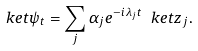Convert formula to latex. <formula><loc_0><loc_0><loc_500><loc_500>\ k e t { \psi _ { t } } = \sum _ { j } \alpha _ { j } e ^ { - i \lambda _ { j } t } \ k e t { z _ { j } } .</formula> 